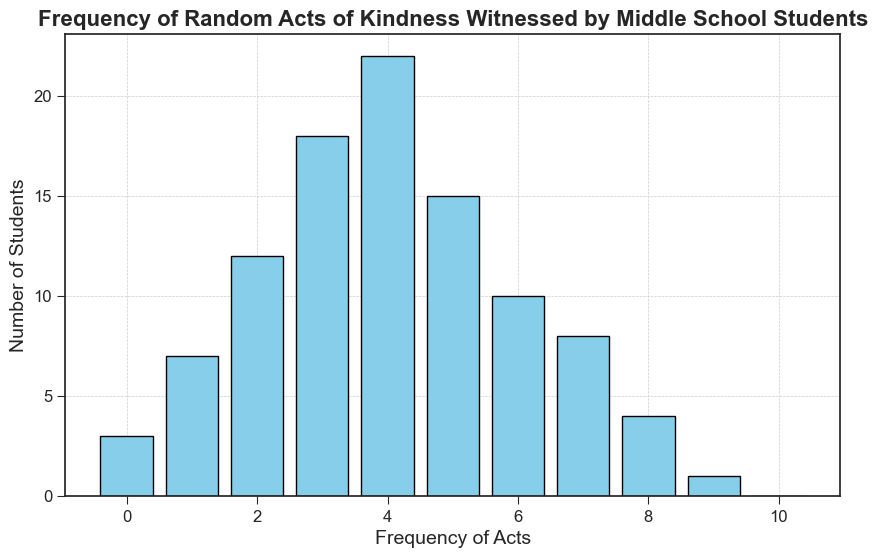What's the most common frequency of acts of kindness witnessed by students? The most common frequency is represented by the tallest bar in the histogram. Here, the tallest bar corresponds to the frequency of 4 acts.
Answer: 4 By how much does the frequency of 4 acts exceed the frequency of 7 acts? To find the difference, we subtract the count for the frequency of 7 acts (8 students) from the count for the frequency of 4 acts (22 students). Thus, 22 - 8 = 14.
Answer: 14 What is the total number of students who witnessed between 3 and 6 acts of kindness? We sum the counts of students who witnessed 3, 4, 5, and 6 acts. That is: 18 (3 acts) + 22 (4 acts) + 15 (5 acts) + 10 (6 acts) = 65.
Answer: 65 Which frequency had the fewest students witnessing acts, and how many students was that? The frequency with the fewest students corresponds to the shortest bar, which is frequency 9 acts, with 1 student witnessing it.
Answer: 9 and 1 Compare the number of students who witnessed 0 acts versus those who witnessed 8 acts. Which group is larger and by how many? The number of students who witnessed 0 acts is 3, and the number who witnessed 8 acts is 4. Comparing these, 4 (8 acts) - 3 (0 acts) = 1. This means more students witnessed 8 acts by 1 student.
Answer: 8 acts by 1 How many more students witnessed 5 acts compared to those who witnessed 2 acts? The number of students who witnessed 5 acts is 15, and those who witnessed 2 acts is 12. The difference is 15 - 12 = 3.
Answer: 3 What's the average frequency of acts witnessed by the students? To find the average frequency, multiply each frequency by its count, sum these products, then divide by the total number of students. (0*3 + 1*7 + 2*12 + 3*18 + 4*22 + 5*15 + 6*10 + 7*8 + 8*4 + 9*1 + 10*0) / 100 = 351 / 100 = 3.51.
Answer: 3.51 